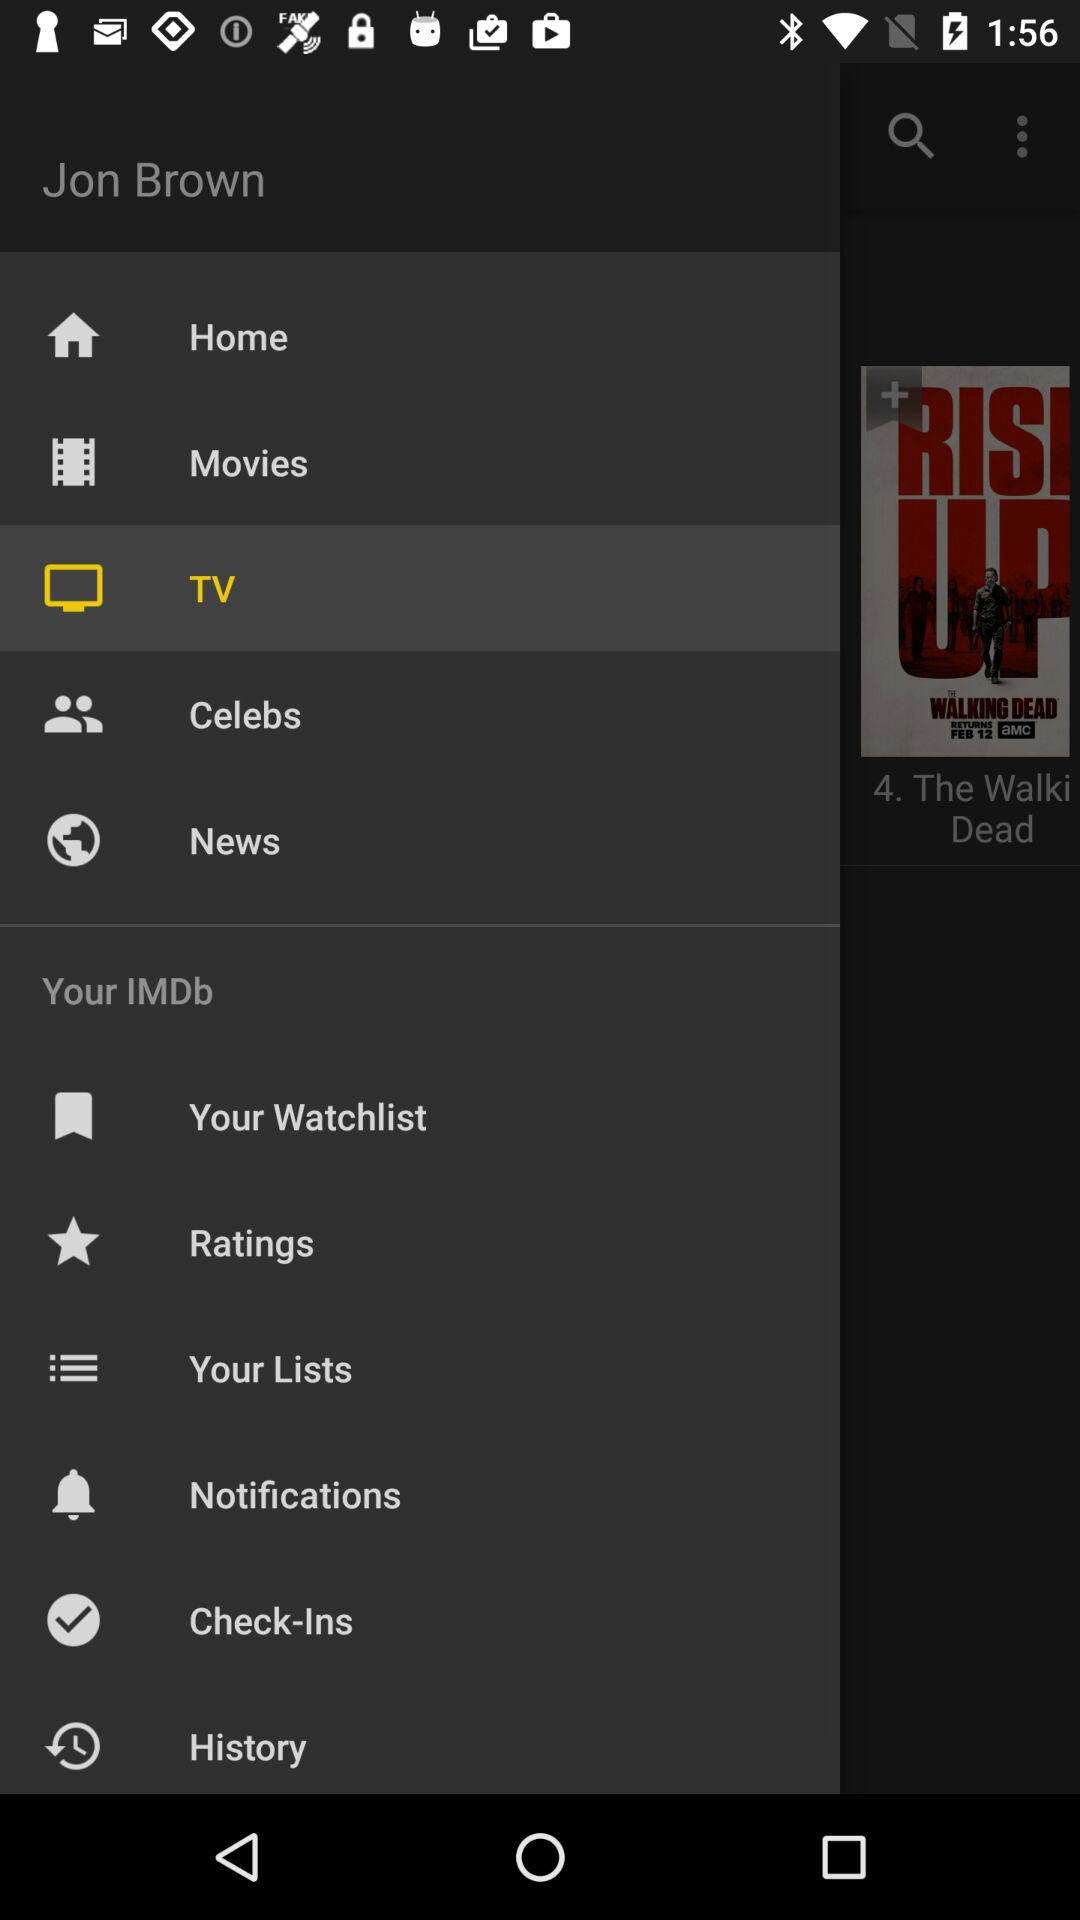Which item is selected? The selected item is "TV". 